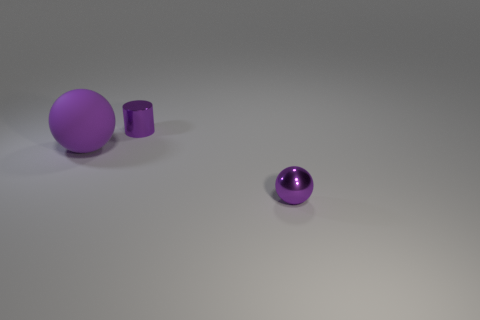Is the size of the metallic object that is behind the metal ball the same as the large purple thing?
Give a very brief answer. No. How many balls have the same size as the cylinder?
Ensure brevity in your answer.  1. What shape is the purple thing that is the same material as the small ball?
Your answer should be very brief. Cylinder. Are there any other small cylinders of the same color as the small shiny cylinder?
Provide a short and direct response. No. What is the material of the large object?
Your answer should be very brief. Rubber. How many things are metallic spheres or small blue spheres?
Keep it short and to the point. 1. What size is the purple object that is behind the purple rubber object?
Offer a very short reply. Small. How many other things are made of the same material as the purple cylinder?
Offer a terse response. 1. Are there any big purple matte objects on the left side of the purple shiny object behind the large purple matte object?
Provide a succinct answer. Yes. What is the size of the shiny cylinder?
Provide a succinct answer. Small. 